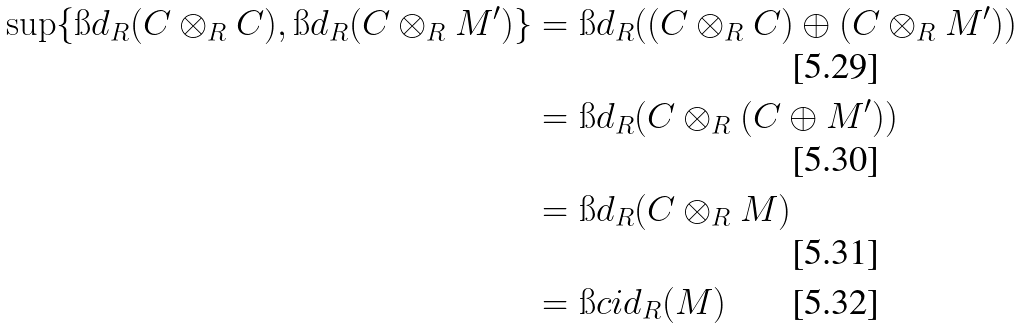<formula> <loc_0><loc_0><loc_500><loc_500>\sup \{ \i d _ { R } ( C \otimes _ { R } C ) , \i d _ { R } ( C \otimes _ { R } M ^ { \prime } ) \} & = \i d _ { R } ( ( C \otimes _ { R } C ) \oplus ( C \otimes _ { R } M ^ { \prime } ) ) \\ & = \i d _ { R } ( C \otimes _ { R } ( C \oplus M ^ { \prime } ) ) \\ & = \i d _ { R } ( C \otimes _ { R } M ) \\ & = \i c i d _ { R } ( M )</formula> 